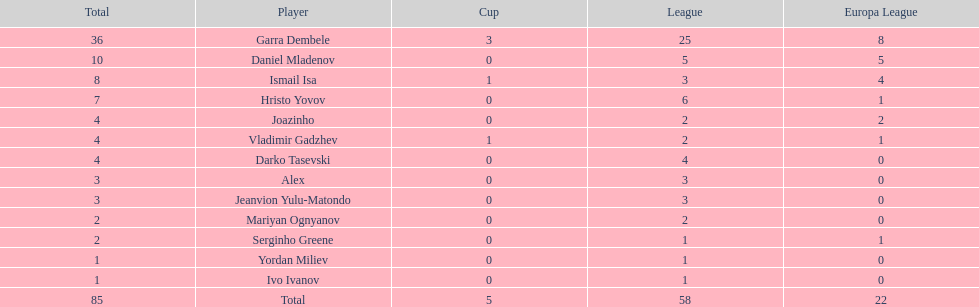How many goals did ismail isa score this season? 8. 